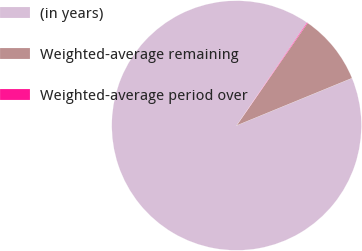<chart> <loc_0><loc_0><loc_500><loc_500><pie_chart><fcel>(in years)<fcel>Weighted-average remaining<fcel>Weighted-average period over<nl><fcel>90.75%<fcel>9.16%<fcel>0.09%<nl></chart> 